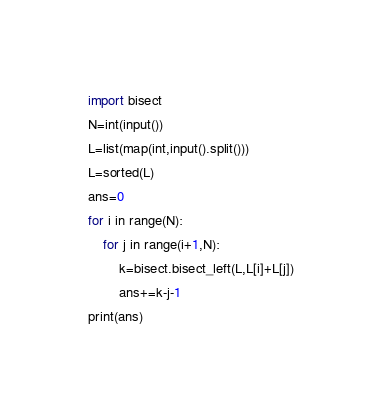Convert code to text. <code><loc_0><loc_0><loc_500><loc_500><_Python_>import bisect
N=int(input())
L=list(map(int,input().split()))
L=sorted(L)
ans=0
for i in range(N):
    for j in range(i+1,N):
        k=bisect.bisect_left(L,L[i]+L[j])
        ans+=k-j-1
print(ans)</code> 